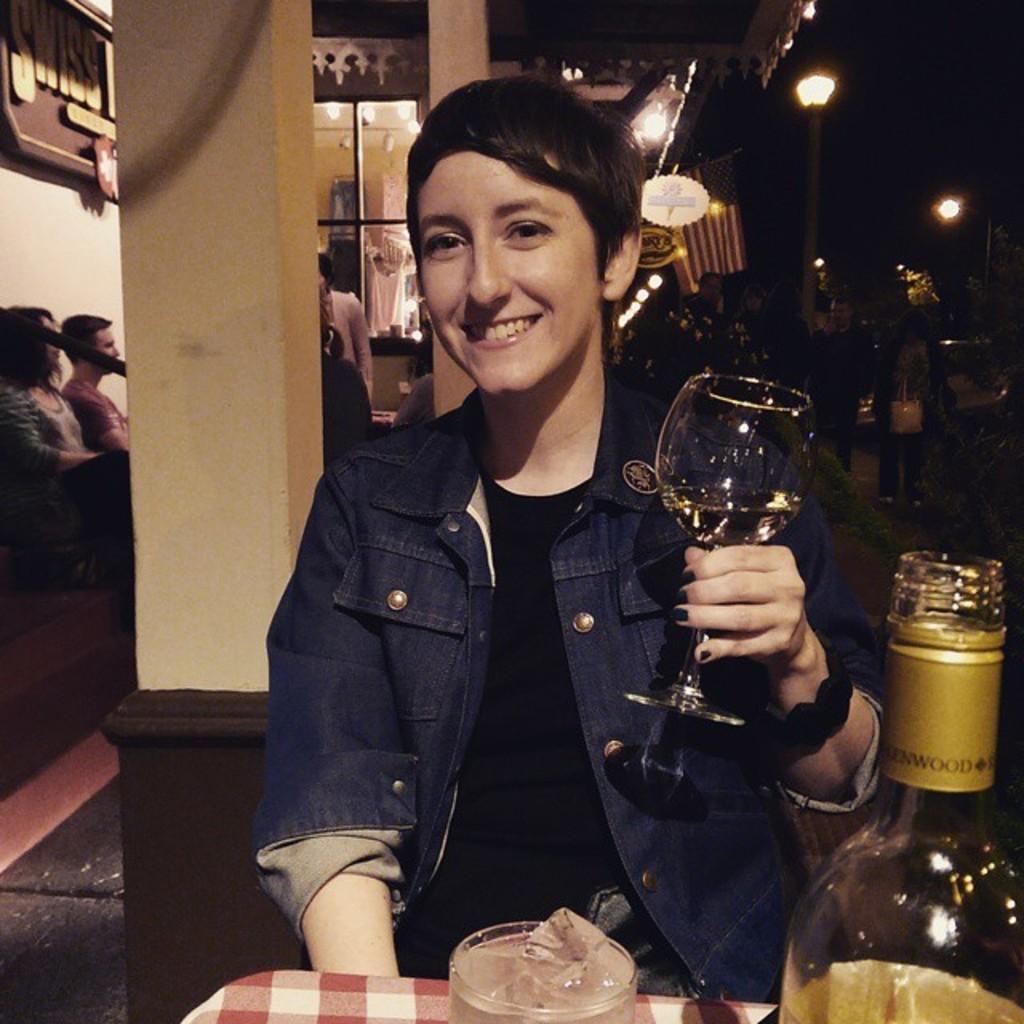Please provide a concise description of this image. In this image we can see a person sitting in front of a table and holding a glass of drink we can see a bottle on the table, on the left side of the image there are two people sitting on a chair, in the background there are some people standing and also we can see a street light in the background. 